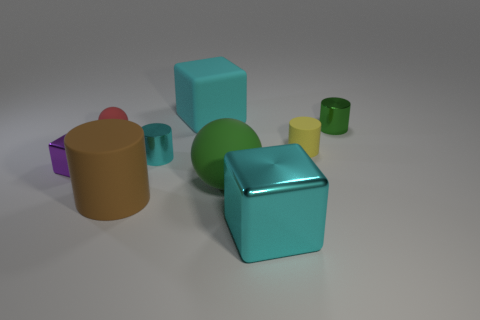Subtract all tiny cylinders. How many cylinders are left? 1 Add 1 cyan metallic blocks. How many objects exist? 10 Subtract 2 blocks. How many blocks are left? 1 Subtract 0 blue balls. How many objects are left? 9 Subtract all cylinders. How many objects are left? 5 Subtract all gray spheres. Subtract all red blocks. How many spheres are left? 2 Subtract all cyan cylinders. How many gray spheres are left? 0 Subtract all gray cylinders. Subtract all green things. How many objects are left? 7 Add 4 brown cylinders. How many brown cylinders are left? 5 Add 8 large rubber cubes. How many large rubber cubes exist? 9 